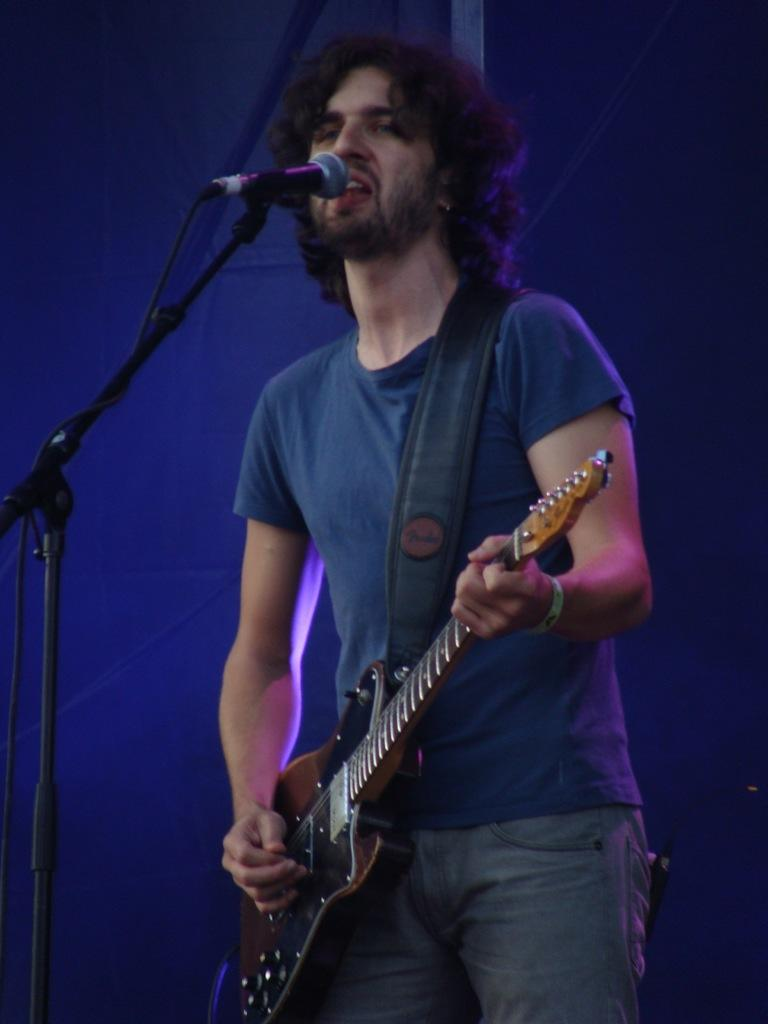What is the person in the image doing? The person is playing a guitar and singing. What is the person wearing? The person is wearing a blue t-shirt and jeans. What object is in front of the person? There is a microphone in front of the person. How many yams are on the person's head in the image? There are no yams present in the image. What type of dolls can be seen playing with the guitar in the image? There are no dolls present in the image; it is a person playing the guitar. 